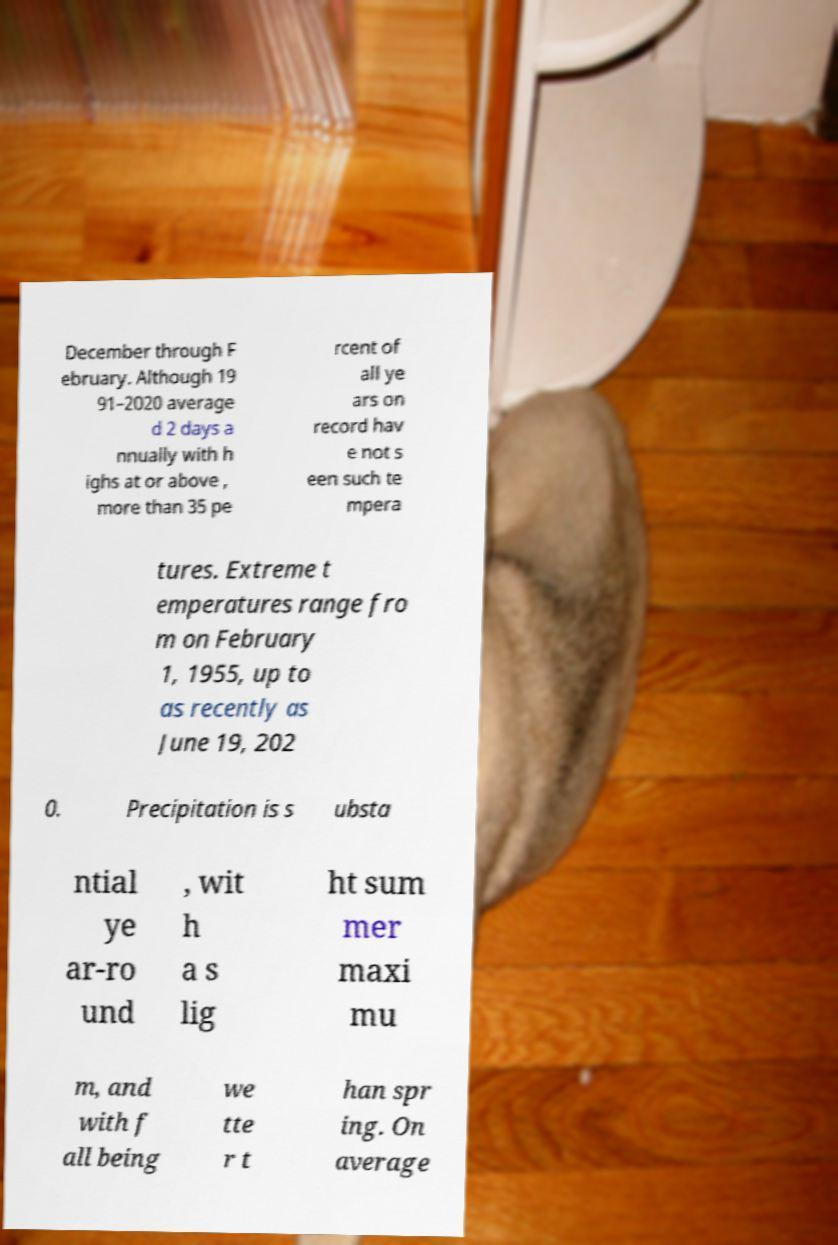Please read and relay the text visible in this image. What does it say? December through F ebruary. Although 19 91–2020 average d 2 days a nnually with h ighs at or above , more than 35 pe rcent of all ye ars on record hav e not s een such te mpera tures. Extreme t emperatures range fro m on February 1, 1955, up to as recently as June 19, 202 0. Precipitation is s ubsta ntial ye ar-ro und , wit h a s lig ht sum mer maxi mu m, and with f all being we tte r t han spr ing. On average 